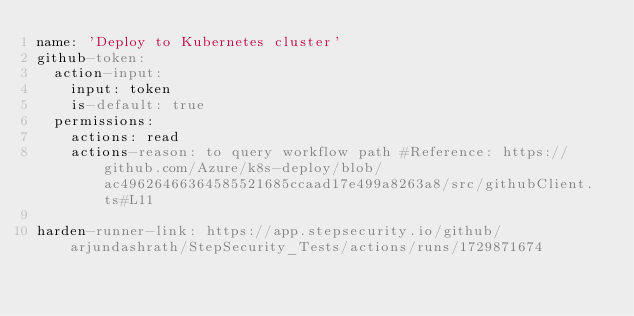Convert code to text. <code><loc_0><loc_0><loc_500><loc_500><_YAML_>name: 'Deploy to Kubernetes cluster'
github-token:
  action-input:
    input: token
    is-default: true
  permissions:
    actions: read
    actions-reason: to query workflow path #Reference: https://github.com/Azure/k8s-deploy/blob/ac49626466364585521685ccaad17e499a8263a8/src/githubClient.ts#L11
    
harden-runner-link: https://app.stepsecurity.io/github/arjundashrath/StepSecurity_Tests/actions/runs/1729871674 
</code> 